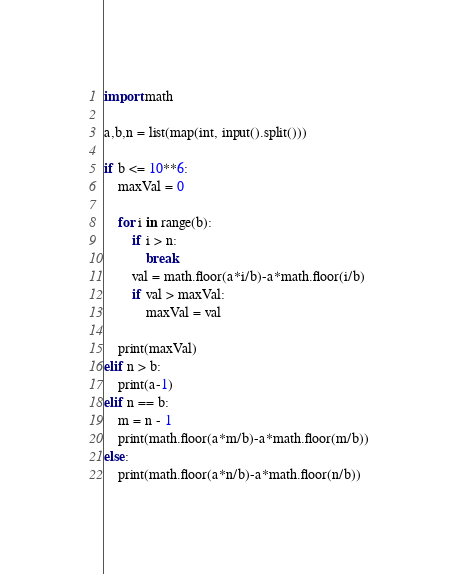<code> <loc_0><loc_0><loc_500><loc_500><_Python_>import math

a,b,n = list(map(int, input().split()))

if b <= 10**6:
    maxVal = 0

    for i in range(b):
        if i > n:
            break
        val = math.floor(a*i/b)-a*math.floor(i/b)
        if val > maxVal:
            maxVal = val

    print(maxVal)
elif n > b:
    print(a-1)
elif n == b:
    m = n - 1
    print(math.floor(a*m/b)-a*math.floor(m/b))
else:
    print(math.floor(a*n/b)-a*math.floor(n/b))
</code> 